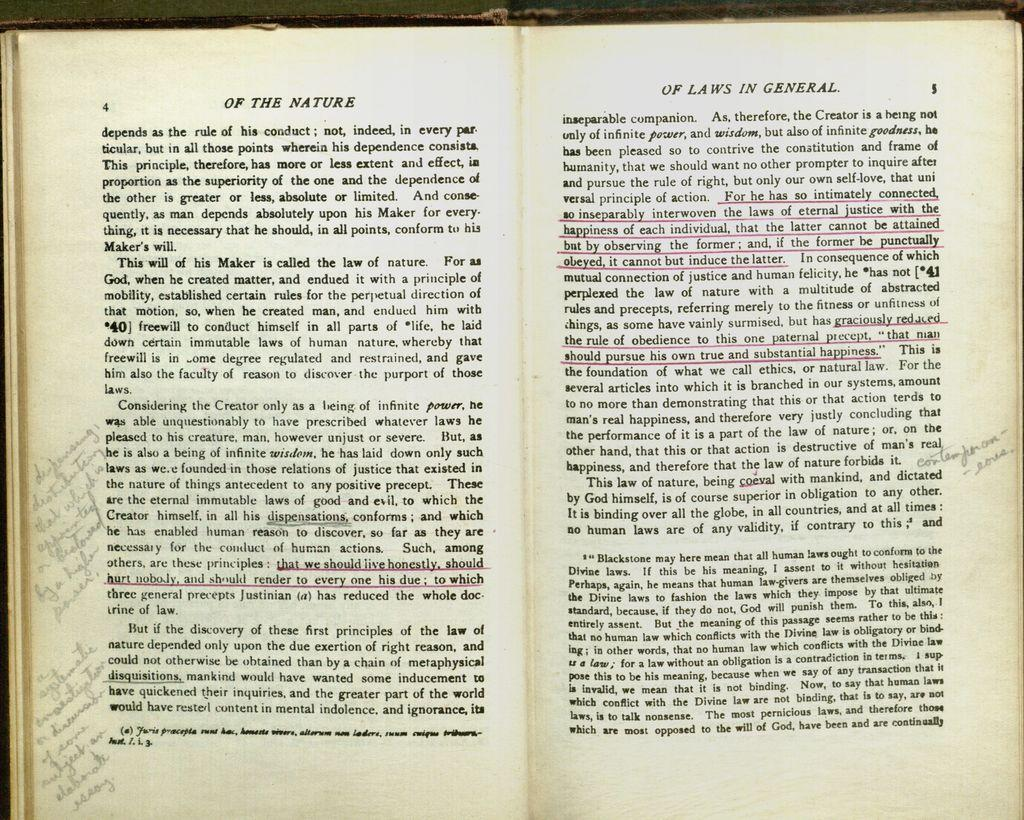<image>
Create a compact narrative representing the image presented. A book with notes in the margins is open to page four and five. 